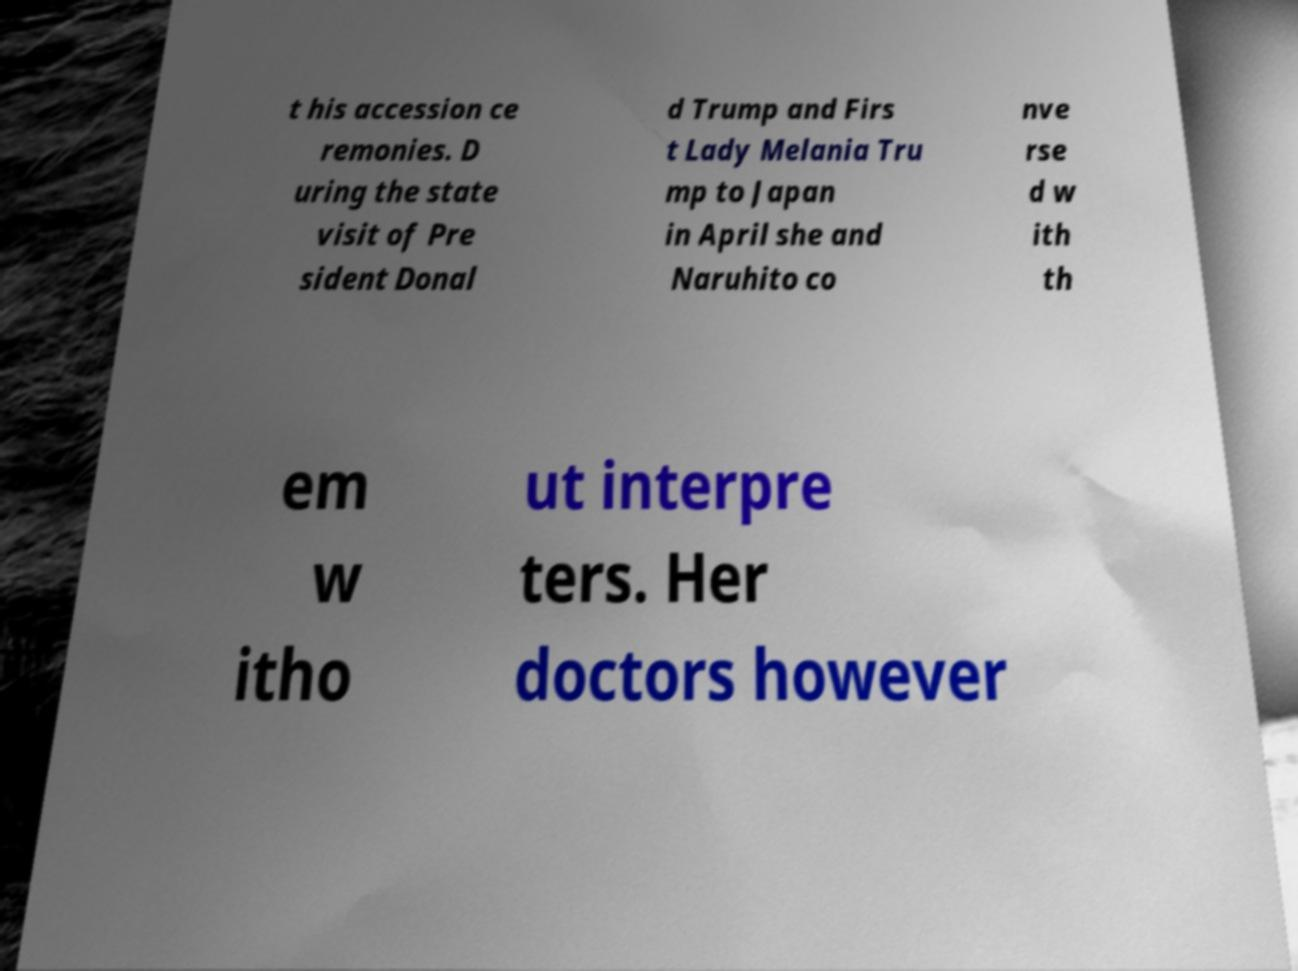Can you read and provide the text displayed in the image?This photo seems to have some interesting text. Can you extract and type it out for me? t his accession ce remonies. D uring the state visit of Pre sident Donal d Trump and Firs t Lady Melania Tru mp to Japan in April she and Naruhito co nve rse d w ith th em w itho ut interpre ters. Her doctors however 